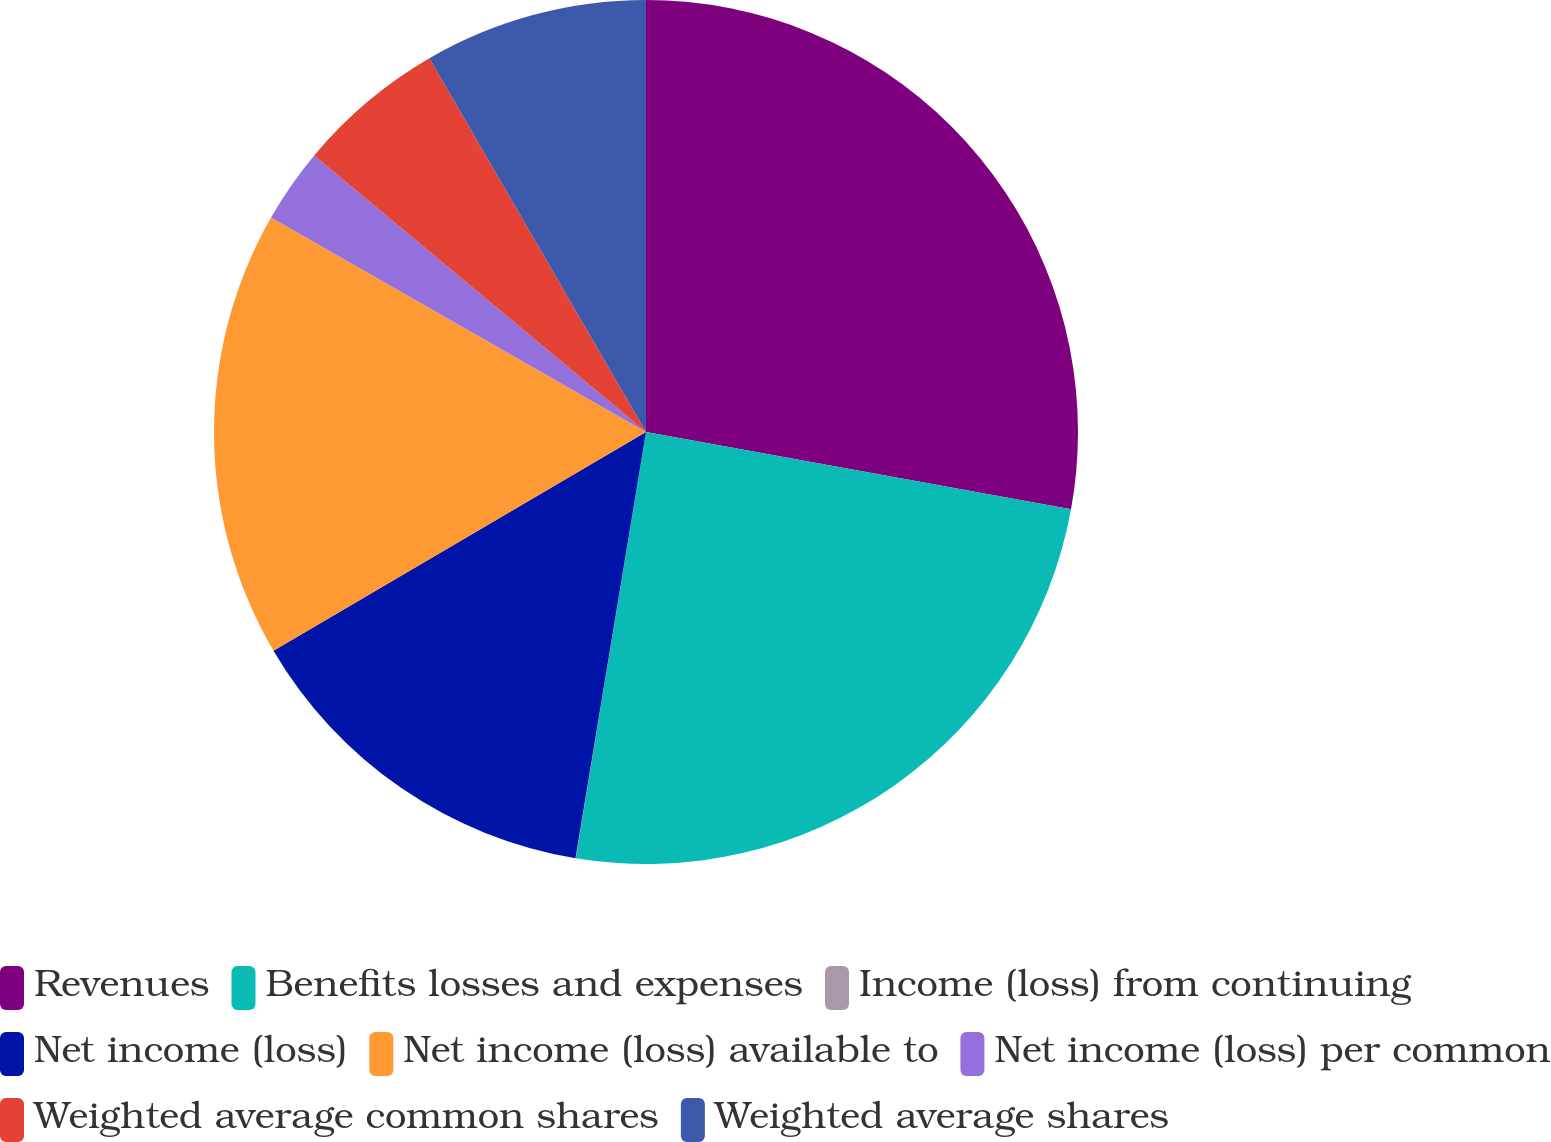Convert chart to OTSL. <chart><loc_0><loc_0><loc_500><loc_500><pie_chart><fcel>Revenues<fcel>Benefits losses and expenses<fcel>Income (loss) from continuing<fcel>Net income (loss)<fcel>Net income (loss) available to<fcel>Net income (loss) per common<fcel>Weighted average common shares<fcel>Weighted average shares<nl><fcel>27.86%<fcel>24.74%<fcel>0.01%<fcel>13.94%<fcel>16.72%<fcel>2.79%<fcel>5.58%<fcel>8.36%<nl></chart> 